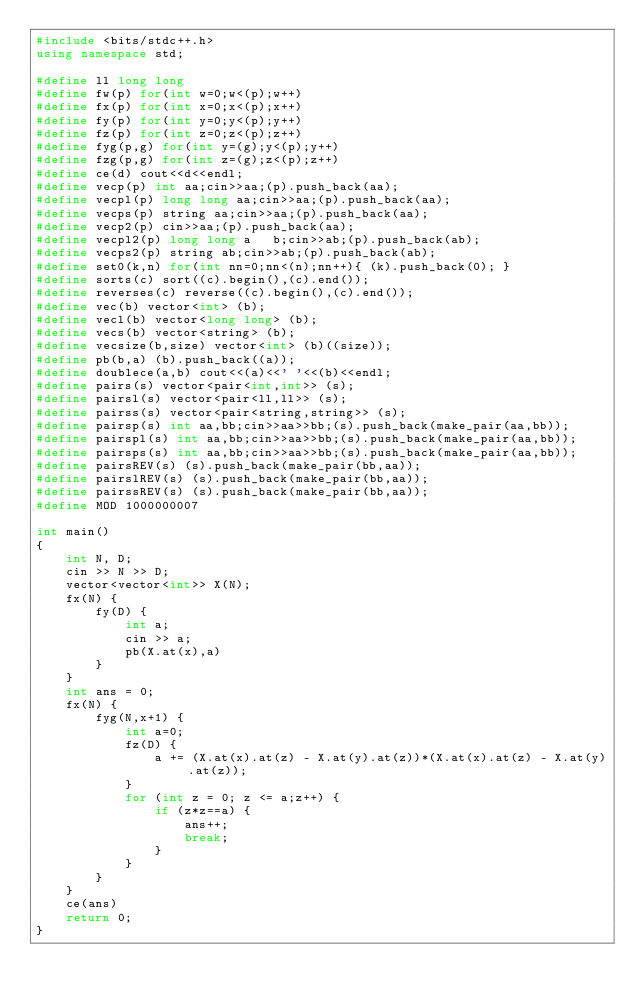<code> <loc_0><loc_0><loc_500><loc_500><_C++_>#include <bits/stdc++.h>
using namespace std;

#define ll long long
#define fw(p) for(int w=0;w<(p);w++)
#define fx(p) for(int x=0;x<(p);x++)
#define fy(p) for(int y=0;y<(p);y++)
#define fz(p) for(int z=0;z<(p);z++)
#define fyg(p,g) for(int y=(g);y<(p);y++)
#define fzg(p,g) for(int z=(g);z<(p);z++)
#define ce(d) cout<<d<<endl;
#define vecp(p) int aa;cin>>aa;(p).push_back(aa);
#define vecpl(p) long long aa;cin>>aa;(p).push_back(aa);
#define vecps(p) string aa;cin>>aa;(p).push_back(aa);
#define vecp2(p) cin>>aa;(p).push_back(aa);
#define vecpl2(p) long long a	b;cin>>ab;(p).push_back(ab);
#define vecps2(p) string ab;cin>>ab;(p).push_back(ab);
#define set0(k,n) for(int nn=0;nn<(n);nn++){ (k).push_back(0); }
#define sorts(c) sort((c).begin(),(c).end());
#define reverses(c) reverse((c).begin(),(c).end());
#define vec(b) vector<int> (b);
#define vecl(b) vector<long long> (b);
#define vecs(b) vector<string> (b);
#define vecsize(b,size) vector<int> (b)((size));
#define pb(b,a) (b).push_back((a));
#define doublece(a,b) cout<<(a)<<' '<<(b)<<endl;
#define pairs(s) vector<pair<int,int>> (s);
#define pairsl(s) vector<pair<ll,ll>> (s);
#define pairss(s) vector<pair<string,string>> (s);
#define pairsp(s) int aa,bb;cin>>aa>>bb;(s).push_back(make_pair(aa,bb));
#define pairspl(s) int aa,bb;cin>>aa>>bb;(s).push_back(make_pair(aa,bb));
#define pairsps(s) int aa,bb;cin>>aa>>bb;(s).push_back(make_pair(aa,bb));
#define pairsREV(s) (s).push_back(make_pair(bb,aa));
#define pairslREV(s) (s).push_back(make_pair(bb,aa));
#define pairssREV(s) (s).push_back(make_pair(bb,aa));
#define MOD 1000000007

int main()
{
	int N, D;
	cin >> N >> D;
	vector<vector<int>> X(N);
	fx(N) {
		fy(D) {
			int a; 
			cin >> a;
			pb(X.at(x),a)
		}
	}
	int ans = 0;
	fx(N) {
		fyg(N,x+1) {
			int a=0;
			fz(D) {
				a += (X.at(x).at(z) - X.at(y).at(z))*(X.at(x).at(z) - X.at(y).at(z));
			}
			for (int z = 0; z <= a;z++) {
				if (z*z==a) {
					ans++;
					break;
				}
			}
		}
	}
	ce(ans)
    return 0;
}

</code> 